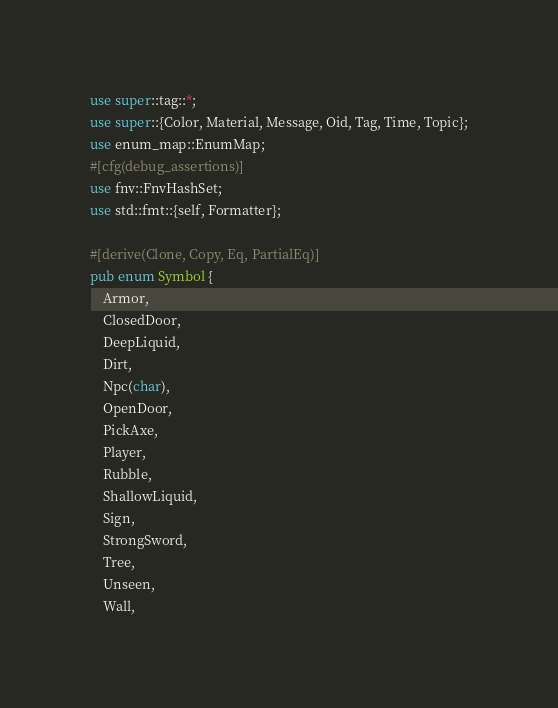<code> <loc_0><loc_0><loc_500><loc_500><_Rust_>use super::tag::*;
use super::{Color, Material, Message, Oid, Tag, Time, Topic};
use enum_map::EnumMap;
#[cfg(debug_assertions)]
use fnv::FnvHashSet;
use std::fmt::{self, Formatter};

#[derive(Clone, Copy, Eq, PartialEq)]
pub enum Symbol {
    Armor,
    ClosedDoor,
    DeepLiquid,
    Dirt,
    Npc(char),
    OpenDoor,
    PickAxe,
    Player,
    Rubble,
    ShallowLiquid,
    Sign,
    StrongSword,
    Tree,
    Unseen,
    Wall,</code> 